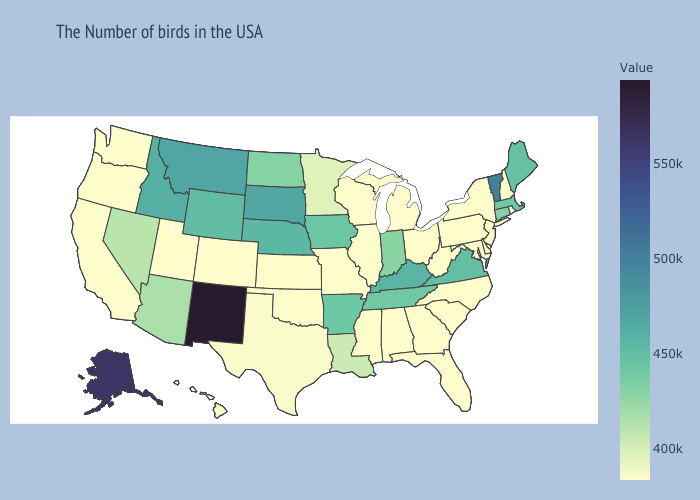Does Vermont have the lowest value in the Northeast?
Short answer required. No. Does Oklahoma have the highest value in the South?
Keep it brief. No. Which states hav the highest value in the Northeast?
Concise answer only. Vermont. Which states hav the highest value in the Northeast?
Be succinct. Vermont. Among the states that border New Hampshire , does Massachusetts have the lowest value?
Quick response, please. Yes. Which states have the lowest value in the Northeast?
Give a very brief answer. Rhode Island, New Hampshire, New York, New Jersey, Pennsylvania. Does Louisiana have the lowest value in the South?
Keep it brief. No. Does Alaska have a higher value than New Mexico?
Short answer required. No. Among the states that border Kansas , which have the lowest value?
Answer briefly. Missouri, Oklahoma, Colorado. 